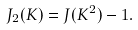<formula> <loc_0><loc_0><loc_500><loc_500>J _ { 2 } ( K ) = J ( K ^ { 2 } ) - 1 .</formula> 